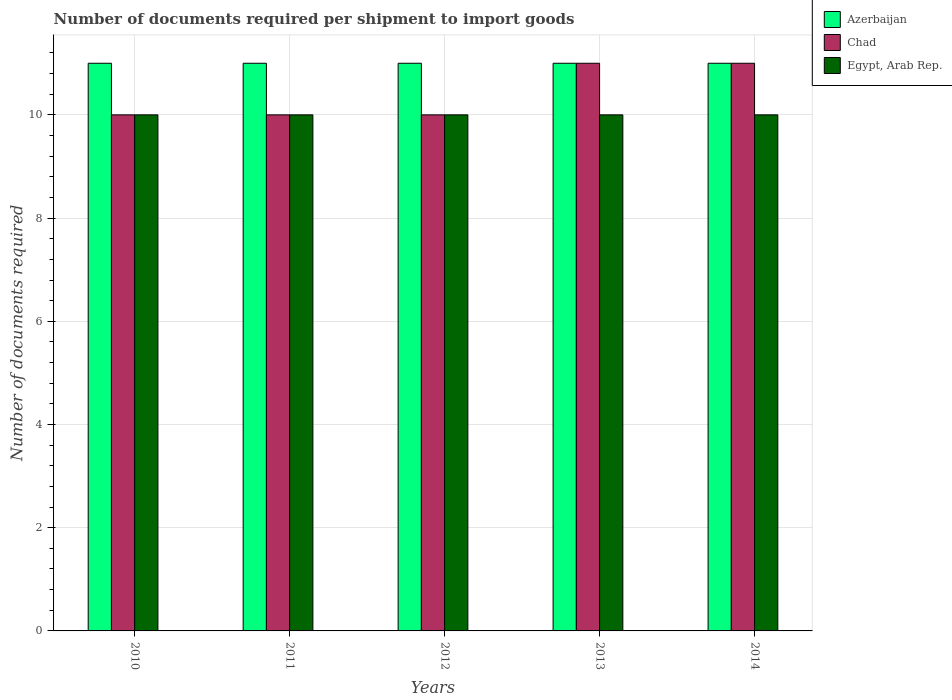How many different coloured bars are there?
Offer a very short reply. 3. How many groups of bars are there?
Your answer should be very brief. 5. Are the number of bars per tick equal to the number of legend labels?
Ensure brevity in your answer.  Yes. Are the number of bars on each tick of the X-axis equal?
Make the answer very short. Yes. How many bars are there on the 5th tick from the right?
Ensure brevity in your answer.  3. In how many cases, is the number of bars for a given year not equal to the number of legend labels?
Keep it short and to the point. 0. What is the number of documents required per shipment to import goods in Egypt, Arab Rep. in 2012?
Keep it short and to the point. 10. Across all years, what is the maximum number of documents required per shipment to import goods in Egypt, Arab Rep.?
Provide a short and direct response. 10. Across all years, what is the minimum number of documents required per shipment to import goods in Azerbaijan?
Make the answer very short. 11. In which year was the number of documents required per shipment to import goods in Egypt, Arab Rep. minimum?
Your answer should be compact. 2010. What is the total number of documents required per shipment to import goods in Egypt, Arab Rep. in the graph?
Keep it short and to the point. 50. What is the difference between the number of documents required per shipment to import goods in Azerbaijan in 2011 and that in 2014?
Keep it short and to the point. 0. What is the difference between the number of documents required per shipment to import goods in Egypt, Arab Rep. in 2014 and the number of documents required per shipment to import goods in Azerbaijan in 2012?
Ensure brevity in your answer.  -1. In the year 2010, what is the difference between the number of documents required per shipment to import goods in Egypt, Arab Rep. and number of documents required per shipment to import goods in Chad?
Offer a very short reply. 0. What is the ratio of the number of documents required per shipment to import goods in Egypt, Arab Rep. in 2010 to that in 2014?
Keep it short and to the point. 1. Is the number of documents required per shipment to import goods in Chad in 2011 less than that in 2012?
Provide a succinct answer. No. What is the difference between the highest and the second highest number of documents required per shipment to import goods in Chad?
Provide a succinct answer. 0. What does the 1st bar from the left in 2010 represents?
Ensure brevity in your answer.  Azerbaijan. What does the 3rd bar from the right in 2014 represents?
Your answer should be compact. Azerbaijan. Are all the bars in the graph horizontal?
Make the answer very short. No. Does the graph contain grids?
Your answer should be compact. Yes. How many legend labels are there?
Ensure brevity in your answer.  3. What is the title of the graph?
Your response must be concise. Number of documents required per shipment to import goods. Does "Gambia, The" appear as one of the legend labels in the graph?
Your answer should be very brief. No. What is the label or title of the Y-axis?
Your answer should be very brief. Number of documents required. What is the Number of documents required in Azerbaijan in 2010?
Offer a terse response. 11. What is the Number of documents required of Egypt, Arab Rep. in 2010?
Offer a very short reply. 10. What is the Number of documents required of Chad in 2011?
Give a very brief answer. 10. What is the Number of documents required in Azerbaijan in 2012?
Provide a succinct answer. 11. What is the Number of documents required of Chad in 2013?
Your response must be concise. 11. Across all years, what is the maximum Number of documents required of Azerbaijan?
Provide a succinct answer. 11. Across all years, what is the maximum Number of documents required in Chad?
Offer a terse response. 11. What is the total Number of documents required of Chad in the graph?
Offer a terse response. 52. What is the total Number of documents required of Egypt, Arab Rep. in the graph?
Give a very brief answer. 50. What is the difference between the Number of documents required in Azerbaijan in 2010 and that in 2011?
Offer a very short reply. 0. What is the difference between the Number of documents required in Chad in 2010 and that in 2011?
Your response must be concise. 0. What is the difference between the Number of documents required of Azerbaijan in 2010 and that in 2013?
Your answer should be compact. 0. What is the difference between the Number of documents required in Chad in 2010 and that in 2014?
Ensure brevity in your answer.  -1. What is the difference between the Number of documents required of Egypt, Arab Rep. in 2010 and that in 2014?
Offer a terse response. 0. What is the difference between the Number of documents required in Chad in 2011 and that in 2013?
Offer a very short reply. -1. What is the difference between the Number of documents required in Egypt, Arab Rep. in 2011 and that in 2013?
Offer a very short reply. 0. What is the difference between the Number of documents required in Azerbaijan in 2011 and that in 2014?
Your answer should be very brief. 0. What is the difference between the Number of documents required of Chad in 2012 and that in 2013?
Provide a short and direct response. -1. What is the difference between the Number of documents required of Egypt, Arab Rep. in 2012 and that in 2013?
Your answer should be very brief. 0. What is the difference between the Number of documents required of Azerbaijan in 2012 and that in 2014?
Make the answer very short. 0. What is the difference between the Number of documents required of Chad in 2012 and that in 2014?
Give a very brief answer. -1. What is the difference between the Number of documents required in Egypt, Arab Rep. in 2012 and that in 2014?
Offer a terse response. 0. What is the difference between the Number of documents required in Azerbaijan in 2013 and that in 2014?
Your answer should be compact. 0. What is the difference between the Number of documents required in Chad in 2013 and that in 2014?
Ensure brevity in your answer.  0. What is the difference between the Number of documents required of Azerbaijan in 2010 and the Number of documents required of Egypt, Arab Rep. in 2011?
Offer a terse response. 1. What is the difference between the Number of documents required in Azerbaijan in 2010 and the Number of documents required in Chad in 2012?
Provide a short and direct response. 1. What is the difference between the Number of documents required of Azerbaijan in 2010 and the Number of documents required of Egypt, Arab Rep. in 2012?
Make the answer very short. 1. What is the difference between the Number of documents required in Azerbaijan in 2010 and the Number of documents required in Chad in 2013?
Provide a short and direct response. 0. What is the difference between the Number of documents required of Azerbaijan in 2010 and the Number of documents required of Chad in 2014?
Your answer should be very brief. 0. What is the difference between the Number of documents required in Azerbaijan in 2010 and the Number of documents required in Egypt, Arab Rep. in 2014?
Offer a very short reply. 1. What is the difference between the Number of documents required in Chad in 2010 and the Number of documents required in Egypt, Arab Rep. in 2014?
Make the answer very short. 0. What is the difference between the Number of documents required in Azerbaijan in 2011 and the Number of documents required in Chad in 2012?
Provide a short and direct response. 1. What is the difference between the Number of documents required of Azerbaijan in 2011 and the Number of documents required of Egypt, Arab Rep. in 2012?
Your response must be concise. 1. What is the difference between the Number of documents required in Chad in 2011 and the Number of documents required in Egypt, Arab Rep. in 2012?
Provide a succinct answer. 0. What is the difference between the Number of documents required of Azerbaijan in 2011 and the Number of documents required of Egypt, Arab Rep. in 2013?
Offer a very short reply. 1. What is the difference between the Number of documents required of Azerbaijan in 2011 and the Number of documents required of Chad in 2014?
Your answer should be compact. 0. What is the difference between the Number of documents required of Azerbaijan in 2012 and the Number of documents required of Chad in 2013?
Your response must be concise. 0. What is the difference between the Number of documents required in Azerbaijan in 2012 and the Number of documents required in Chad in 2014?
Your answer should be very brief. 0. What is the difference between the Number of documents required of Azerbaijan in 2012 and the Number of documents required of Egypt, Arab Rep. in 2014?
Give a very brief answer. 1. What is the difference between the Number of documents required in Chad in 2012 and the Number of documents required in Egypt, Arab Rep. in 2014?
Your response must be concise. 0. What is the difference between the Number of documents required in Azerbaijan in 2013 and the Number of documents required in Chad in 2014?
Your answer should be compact. 0. In the year 2010, what is the difference between the Number of documents required in Azerbaijan and Number of documents required in Egypt, Arab Rep.?
Your answer should be compact. 1. In the year 2011, what is the difference between the Number of documents required in Azerbaijan and Number of documents required in Chad?
Your response must be concise. 1. In the year 2011, what is the difference between the Number of documents required of Azerbaijan and Number of documents required of Egypt, Arab Rep.?
Your answer should be very brief. 1. In the year 2012, what is the difference between the Number of documents required in Azerbaijan and Number of documents required in Egypt, Arab Rep.?
Your response must be concise. 1. In the year 2013, what is the difference between the Number of documents required in Azerbaijan and Number of documents required in Egypt, Arab Rep.?
Provide a short and direct response. 1. In the year 2013, what is the difference between the Number of documents required in Chad and Number of documents required in Egypt, Arab Rep.?
Your answer should be compact. 1. In the year 2014, what is the difference between the Number of documents required in Azerbaijan and Number of documents required in Chad?
Keep it short and to the point. 0. In the year 2014, what is the difference between the Number of documents required in Chad and Number of documents required in Egypt, Arab Rep.?
Ensure brevity in your answer.  1. What is the ratio of the Number of documents required in Chad in 2010 to that in 2011?
Offer a terse response. 1. What is the ratio of the Number of documents required in Egypt, Arab Rep. in 2010 to that in 2011?
Your response must be concise. 1. What is the ratio of the Number of documents required of Azerbaijan in 2010 to that in 2012?
Provide a short and direct response. 1. What is the ratio of the Number of documents required of Chad in 2010 to that in 2012?
Your response must be concise. 1. What is the ratio of the Number of documents required of Chad in 2010 to that in 2013?
Ensure brevity in your answer.  0.91. What is the ratio of the Number of documents required of Azerbaijan in 2010 to that in 2014?
Your response must be concise. 1. What is the ratio of the Number of documents required in Chad in 2010 to that in 2014?
Offer a very short reply. 0.91. What is the ratio of the Number of documents required of Egypt, Arab Rep. in 2010 to that in 2014?
Offer a terse response. 1. What is the ratio of the Number of documents required of Azerbaijan in 2011 to that in 2013?
Keep it short and to the point. 1. What is the ratio of the Number of documents required in Chad in 2011 to that in 2013?
Your answer should be compact. 0.91. What is the ratio of the Number of documents required in Egypt, Arab Rep. in 2011 to that in 2013?
Offer a terse response. 1. What is the ratio of the Number of documents required in Chad in 2011 to that in 2014?
Your response must be concise. 0.91. What is the ratio of the Number of documents required of Egypt, Arab Rep. in 2011 to that in 2014?
Provide a short and direct response. 1. What is the ratio of the Number of documents required of Azerbaijan in 2012 to that in 2013?
Your response must be concise. 1. What is the ratio of the Number of documents required in Egypt, Arab Rep. in 2012 to that in 2013?
Your answer should be very brief. 1. What is the ratio of the Number of documents required of Chad in 2013 to that in 2014?
Ensure brevity in your answer.  1. What is the ratio of the Number of documents required in Egypt, Arab Rep. in 2013 to that in 2014?
Provide a short and direct response. 1. What is the difference between the highest and the second highest Number of documents required in Chad?
Your answer should be very brief. 0. What is the difference between the highest and the second highest Number of documents required in Egypt, Arab Rep.?
Your response must be concise. 0. What is the difference between the highest and the lowest Number of documents required in Chad?
Keep it short and to the point. 1. 